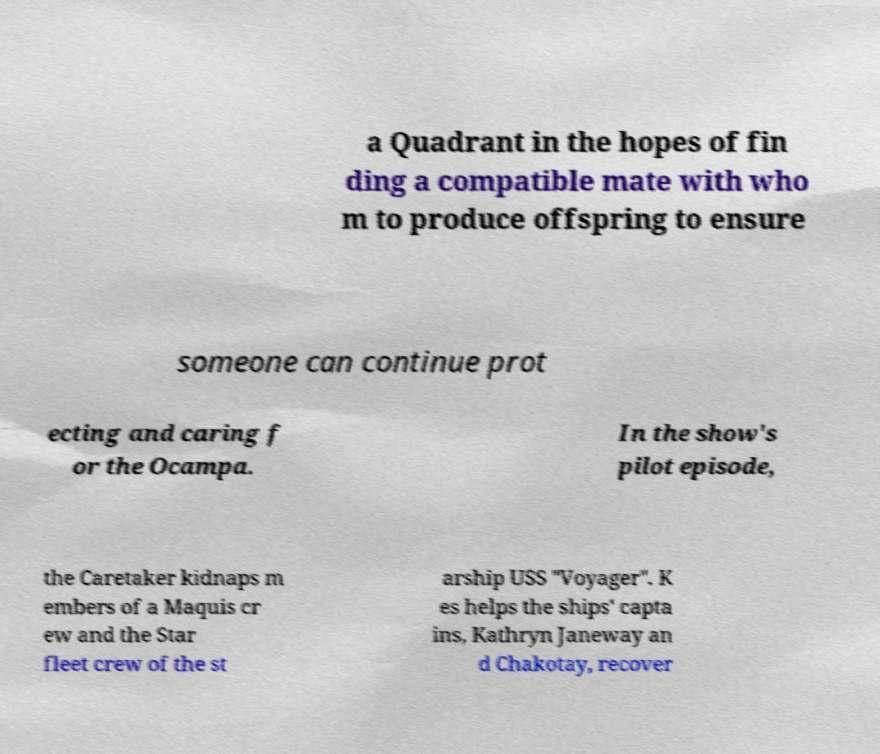Could you assist in decoding the text presented in this image and type it out clearly? a Quadrant in the hopes of fin ding a compatible mate with who m to produce offspring to ensure someone can continue prot ecting and caring f or the Ocampa. In the show's pilot episode, the Caretaker kidnaps m embers of a Maquis cr ew and the Star fleet crew of the st arship USS "Voyager". K es helps the ships' capta ins, Kathryn Janeway an d Chakotay, recover 